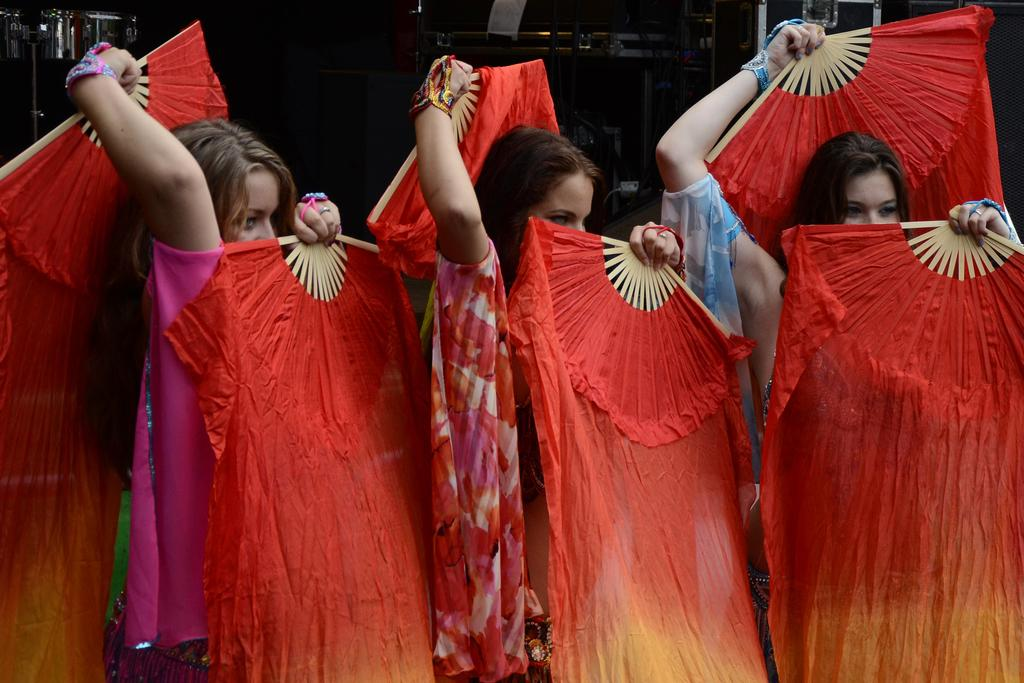What is happening in the foreground of the image? There are people with costumes in the foreground of the image. What can be observed about the background of the image? The background of the image is dark. What type of system is being used by the friends in the image? There is no mention of friends or a system in the image; it only shows people with costumes in the foreground and a dark background. 